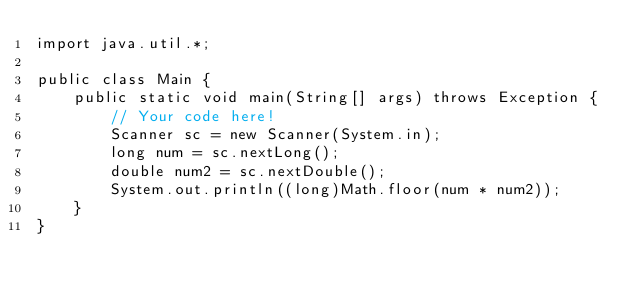Convert code to text. <code><loc_0><loc_0><loc_500><loc_500><_Java_>import java.util.*;

public class Main {
    public static void main(String[] args) throws Exception {
        // Your code here!
        Scanner sc = new Scanner(System.in);
        long num = sc.nextLong();
        double num2 = sc.nextDouble();
        System.out.println((long)Math.floor(num * num2));
    }
}
</code> 